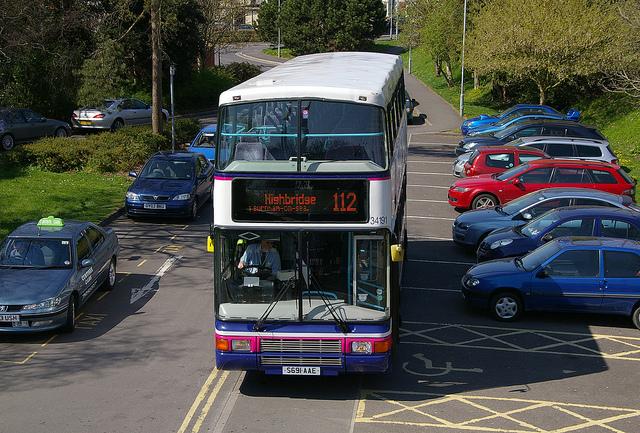What is the number on the bus?
Short answer required. 112. Where is the bus going?
Quick response, please. Highbridge. What is that coming out of the front of the van?
Give a very brief answer. Light. How many cars are there?
Short answer required. 12. 